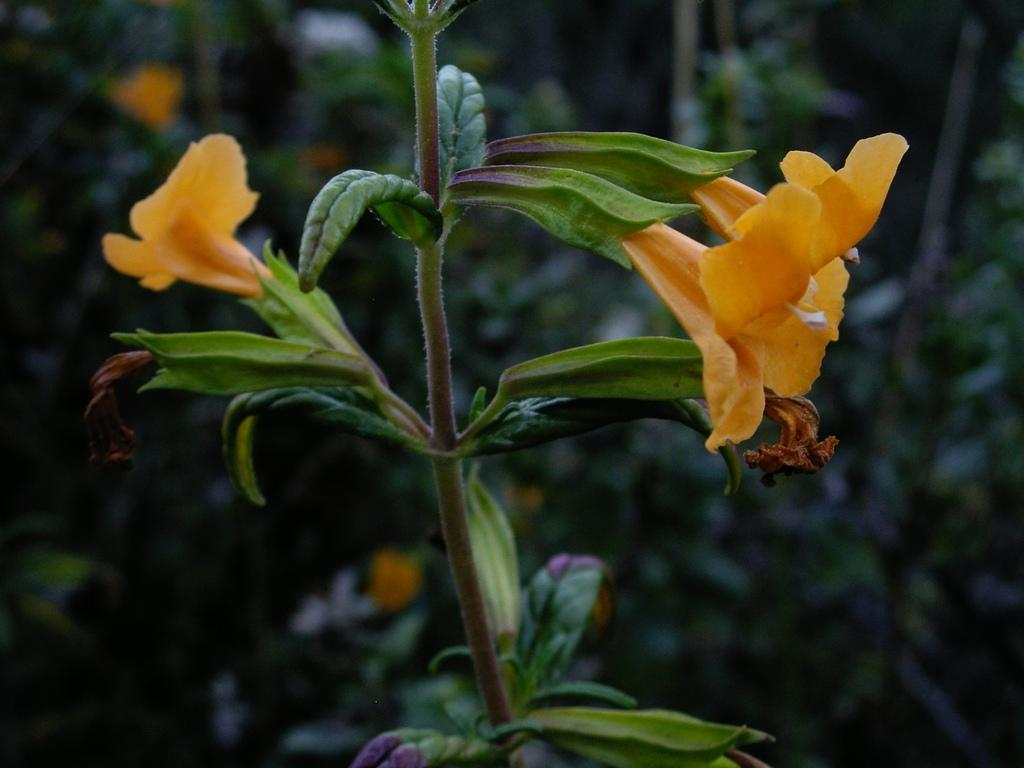What color is the flower in the image? The flower in the image is orange. Is the flower part of a larger plant? Yes, the flower is attached to a plant. What can be seen in the background of the image? There are other plants visible in the background of the image, but they are blurry. Can you see a nest in the image? There is no nest present in the image. Is the image taken from a moving vehicle? The image does not provide any information about the location or movement of the camera, so it cannot be determined if it was taken while driving. 